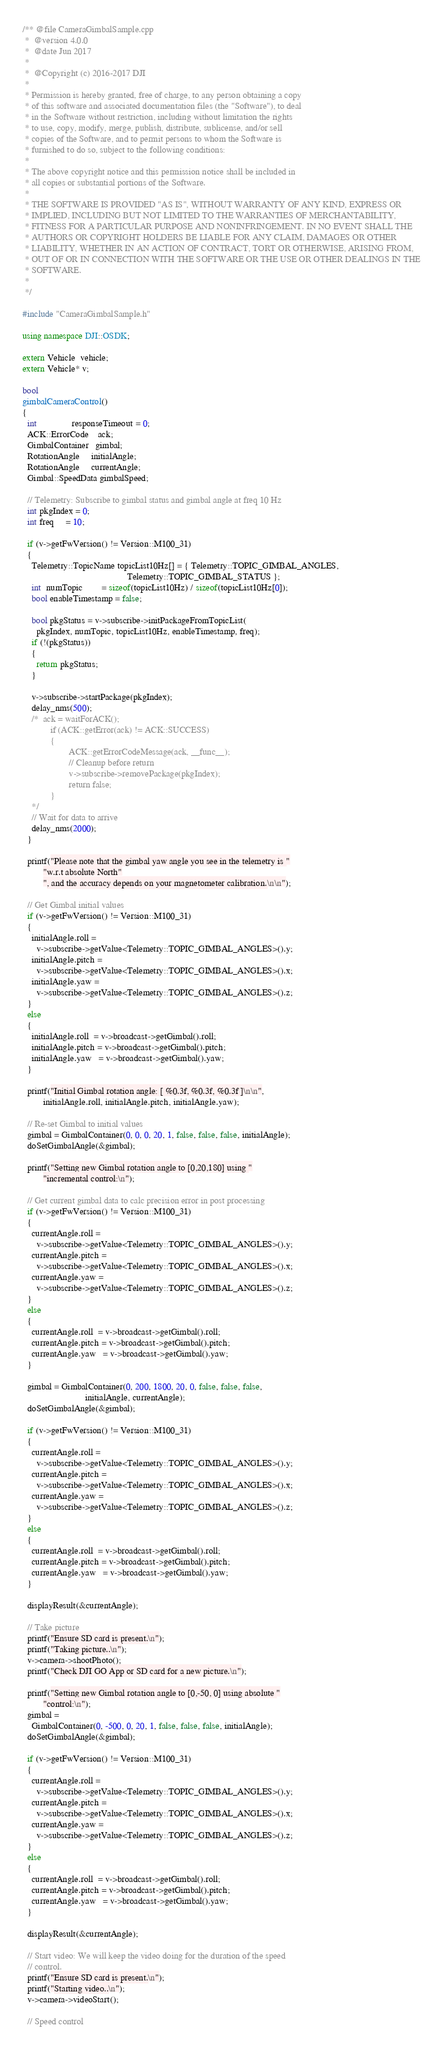<code> <loc_0><loc_0><loc_500><loc_500><_C++_>/** @file CameraGimbalSample.cpp
 *  @version 4.0.0
 *  @date Jun 2017
 *
 *  @Copyright (c) 2016-2017 DJI
 *
 * Permission is hereby granted, free of charge, to any person obtaining a copy
 * of this software and associated documentation files (the "Software"), to deal
 * in the Software without restriction, including without limitation the rights
 * to use, copy, modify, merge, publish, distribute, sublicense, and/or sell
 * copies of the Software, and to permit persons to whom the Software is
 * furnished to do so, subject to the following conditions:
 *
 * The above copyright notice and this permission notice shall be included in
 * all copies or substantial portions of the Software.
 *
 * THE SOFTWARE IS PROVIDED "AS IS", WITHOUT WARRANTY OF ANY KIND, EXPRESS OR
 * IMPLIED, INCLUDING BUT NOT LIMITED TO THE WARRANTIES OF MERCHANTABILITY,
 * FITNESS FOR A PARTICULAR PURPOSE AND NONINFRINGEMENT. IN NO EVENT SHALL THE
 * AUTHORS OR COPYRIGHT HOLDERS BE LIABLE FOR ANY CLAIM, DAMAGES OR OTHER
 * LIABILITY, WHETHER IN AN ACTION OF CONTRACT, TORT OR OTHERWISE, ARISING FROM,
 * OUT OF OR IN CONNECTION WITH THE SOFTWARE OR THE USE OR OTHER DEALINGS IN THE
 * SOFTWARE.
 *
 */

#include "CameraGimbalSample.h"

using namespace DJI::OSDK;

extern Vehicle  vehicle;
extern Vehicle* v;

bool
gimbalCameraControl()
{
  int               responseTimeout = 0;
  ACK::ErrorCode    ack;
  GimbalContainer   gimbal;
  RotationAngle     initialAngle;
  RotationAngle     currentAngle;
  Gimbal::SpeedData gimbalSpeed;

  // Telemetry: Subscribe to gimbal status and gimbal angle at freq 10 Hz
  int pkgIndex = 0;
  int freq     = 10;

  if (v->getFwVersion() != Version::M100_31)
  {
    Telemetry::TopicName topicList10Hz[] = { Telemetry::TOPIC_GIMBAL_ANGLES,
                                             Telemetry::TOPIC_GIMBAL_STATUS };
    int  numTopic        = sizeof(topicList10Hz) / sizeof(topicList10Hz[0]);
    bool enableTimestamp = false;

    bool pkgStatus = v->subscribe->initPackageFromTopicList(
      pkgIndex, numTopic, topicList10Hz, enableTimestamp, freq);
    if (!(pkgStatus))
    {
      return pkgStatus;
    }

    v->subscribe->startPackage(pkgIndex);
    delay_nms(500);
    /*	ack = waitForACK();
            if (ACK::getError(ack) != ACK::SUCCESS)
            {
                    ACK::getErrorCodeMessage(ack, __func__);
                    // Cleanup before return
                    v->subscribe->removePackage(pkgIndex);
                    return false;
            }
    */
    // Wait for data to arrive
    delay_nms(2000);
  }

  printf("Please note that the gimbal yaw angle you see in the telemetry is "
         "w.r.t absolute North"
         ", and the accuracy depends on your magnetometer calibration.\n\n");

  // Get Gimbal initial values
  if (v->getFwVersion() != Version::M100_31)
  {
    initialAngle.roll =
      v->subscribe->getValue<Telemetry::TOPIC_GIMBAL_ANGLES>().y;
    initialAngle.pitch =
      v->subscribe->getValue<Telemetry::TOPIC_GIMBAL_ANGLES>().x;
    initialAngle.yaw =
      v->subscribe->getValue<Telemetry::TOPIC_GIMBAL_ANGLES>().z;
  }
  else
  {
    initialAngle.roll  = v->broadcast->getGimbal().roll;
    initialAngle.pitch = v->broadcast->getGimbal().pitch;
    initialAngle.yaw   = v->broadcast->getGimbal().yaw;
  }

  printf("Initial Gimbal rotation angle: [ %0.3f, %0.3f, %0.3f ]\n\n",
         initialAngle.roll, initialAngle.pitch, initialAngle.yaw);

  // Re-set Gimbal to initial values
  gimbal = GimbalContainer(0, 0, 0, 20, 1, false, false, false, initialAngle);
  doSetGimbalAngle(&gimbal);

  printf("Setting new Gimbal rotation angle to [0,20,180] using "
         "incremental control:\n");

  // Get current gimbal data to calc precision error in post processing
  if (v->getFwVersion() != Version::M100_31)
  {
    currentAngle.roll =
      v->subscribe->getValue<Telemetry::TOPIC_GIMBAL_ANGLES>().y;
    currentAngle.pitch =
      v->subscribe->getValue<Telemetry::TOPIC_GIMBAL_ANGLES>().x;
    currentAngle.yaw =
      v->subscribe->getValue<Telemetry::TOPIC_GIMBAL_ANGLES>().z;
  }
  else
  {
    currentAngle.roll  = v->broadcast->getGimbal().roll;
    currentAngle.pitch = v->broadcast->getGimbal().pitch;
    currentAngle.yaw   = v->broadcast->getGimbal().yaw;
  }

  gimbal = GimbalContainer(0, 200, 1800, 20, 0, false, false, false,
                           initialAngle, currentAngle);
  doSetGimbalAngle(&gimbal);

  if (v->getFwVersion() != Version::M100_31)
  {
    currentAngle.roll =
      v->subscribe->getValue<Telemetry::TOPIC_GIMBAL_ANGLES>().y;
    currentAngle.pitch =
      v->subscribe->getValue<Telemetry::TOPIC_GIMBAL_ANGLES>().x;
    currentAngle.yaw =
      v->subscribe->getValue<Telemetry::TOPIC_GIMBAL_ANGLES>().z;
  }
  else
  {
    currentAngle.roll  = v->broadcast->getGimbal().roll;
    currentAngle.pitch = v->broadcast->getGimbal().pitch;
    currentAngle.yaw   = v->broadcast->getGimbal().yaw;
  }

  displayResult(&currentAngle);

  // Take picture
  printf("Ensure SD card is present.\n");
  printf("Taking picture..\n");
  v->camera->shootPhoto();
  printf("Check DJI GO App or SD card for a new picture.\n");

  printf("Setting new Gimbal rotation angle to [0,-50, 0] using absolute "
         "control:\n");
  gimbal =
    GimbalContainer(0, -500, 0, 20, 1, false, false, false, initialAngle);
  doSetGimbalAngle(&gimbal);

  if (v->getFwVersion() != Version::M100_31)
  {
    currentAngle.roll =
      v->subscribe->getValue<Telemetry::TOPIC_GIMBAL_ANGLES>().y;
    currentAngle.pitch =
      v->subscribe->getValue<Telemetry::TOPIC_GIMBAL_ANGLES>().x;
    currentAngle.yaw =
      v->subscribe->getValue<Telemetry::TOPIC_GIMBAL_ANGLES>().z;
  }
  else
  {
    currentAngle.roll  = v->broadcast->getGimbal().roll;
    currentAngle.pitch = v->broadcast->getGimbal().pitch;
    currentAngle.yaw   = v->broadcast->getGimbal().yaw;
  }

  displayResult(&currentAngle);

  // Start video: We will keep the video doing for the duration of the speed
  // control.
  printf("Ensure SD card is present.\n");
  printf("Starting video..\n");
  v->camera->videoStart();

  // Speed control
</code> 